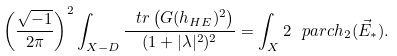<formula> <loc_0><loc_0><loc_500><loc_500>\left ( \frac { \sqrt { - 1 } } { 2 \pi } \right ) ^ { 2 } \int _ { X - D } \frac { \ t r \left ( G ( h _ { H E } ) ^ { 2 } \right ) } { ( 1 + | \lambda | ^ { 2 } ) ^ { 2 } } = \int _ { X } 2 \ p a r c h _ { 2 } ( \vec { E } _ { \ast } ) .</formula> 